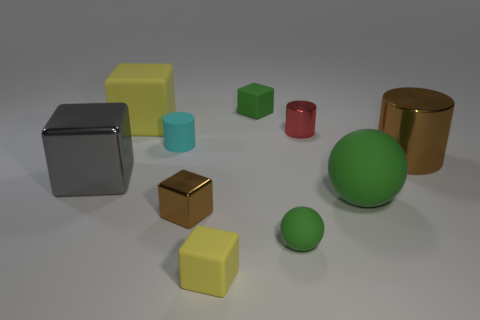Subtract 1 blocks. How many blocks are left? 4 Subtract all cylinders. How many objects are left? 7 Subtract all brown cubes. Subtract all small rubber cubes. How many objects are left? 7 Add 8 brown shiny cubes. How many brown shiny cubes are left? 9 Add 5 small gray things. How many small gray things exist? 5 Subtract 0 gray cylinders. How many objects are left? 10 